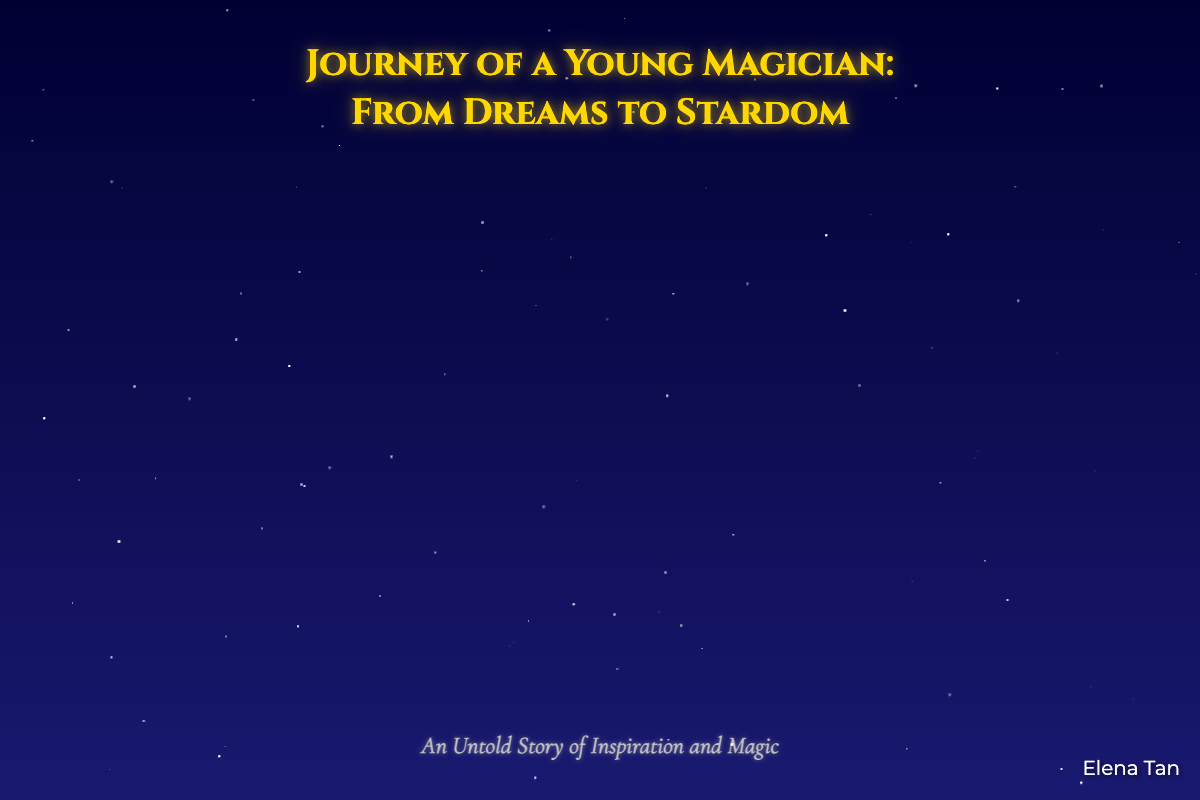What is the title of the book? The title is prominently displayed on the cover in a large font, which reads "Journey of a Young Magician: From Dreams to Stardom."
Answer: Journey of a Young Magician: From Dreams to Stardom Who is the author of the book? The author's name is found at the bottom right of the cover, written in a smaller font.
Answer: Elena Tan What image is featured prominently on the cover? The cover features a young figure gazing up at a starry night sky, symbolizing aspirations.
Answer: Young magician What color is used in the background of the book cover? The background features a gradient transitioning from dark blue to navy, creating a night sky effect.
Answer: Blue to navy How many stars are depicted in the animation? The animation creates 100 stars that randomly appear in the background.
Answer: 100 What does the magical trail leading to Andrew Lee symbolize? It represents the journey and efforts from being an aspiring magician to achieving stardom, highlighting inspiration and aspiration.
Answer: The path to recognition What is the subtitle of the book? Located just below the title, the subtitle adds depth to the title, stating the nature of the story.
Answer: An Untold Story of Inspiration and Magic Where is Andrew Lee's image located on the cover? The image of Andrew Lee is positioned at the top right corner of the cover design.
Answer: Top right corner 